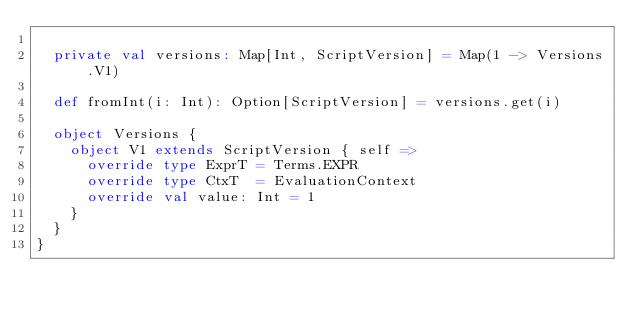Convert code to text. <code><loc_0><loc_0><loc_500><loc_500><_Scala_>
  private val versions: Map[Int, ScriptVersion] = Map(1 -> Versions.V1)

  def fromInt(i: Int): Option[ScriptVersion] = versions.get(i)

  object Versions {
    object V1 extends ScriptVersion { self =>
      override type ExprT = Terms.EXPR
      override type CtxT  = EvaluationContext
      override val value: Int = 1
    }
  }
}
</code> 